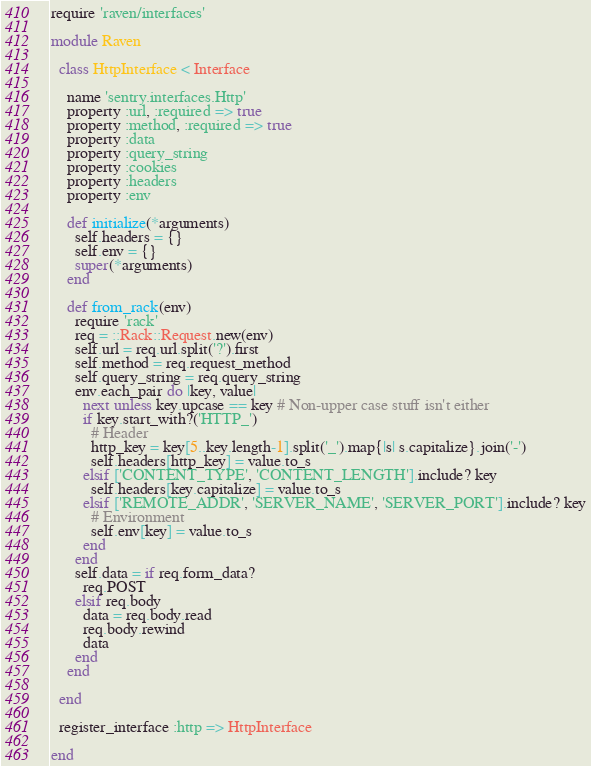Convert code to text. <code><loc_0><loc_0><loc_500><loc_500><_Ruby_>require 'raven/interfaces'

module Raven

  class HttpInterface < Interface

    name 'sentry.interfaces.Http'
    property :url, :required => true
    property :method, :required => true
    property :data
    property :query_string
    property :cookies
    property :headers
    property :env

    def initialize(*arguments)
      self.headers = {}
      self.env = {}
      super(*arguments)
    end

    def from_rack(env)
      require 'rack'
      req = ::Rack::Request.new(env)
      self.url = req.url.split('?').first
      self.method = req.request_method
      self.query_string = req.query_string
      env.each_pair do |key, value|
        next unless key.upcase == key # Non-upper case stuff isn't either
        if key.start_with?('HTTP_')
          # Header
          http_key = key[5..key.length-1].split('_').map{|s| s.capitalize}.join('-')
          self.headers[http_key] = value.to_s
        elsif ['CONTENT_TYPE', 'CONTENT_LENGTH'].include? key
          self.headers[key.capitalize] = value.to_s
        elsif ['REMOTE_ADDR', 'SERVER_NAME', 'SERVER_PORT'].include? key
          # Environment
          self.env[key] = value.to_s
        end
      end
      self.data = if req.form_data?
        req.POST
      elsif req.body
        data = req.body.read
        req.body.rewind
        data
      end
    end

  end

  register_interface :http => HttpInterface

end
</code> 